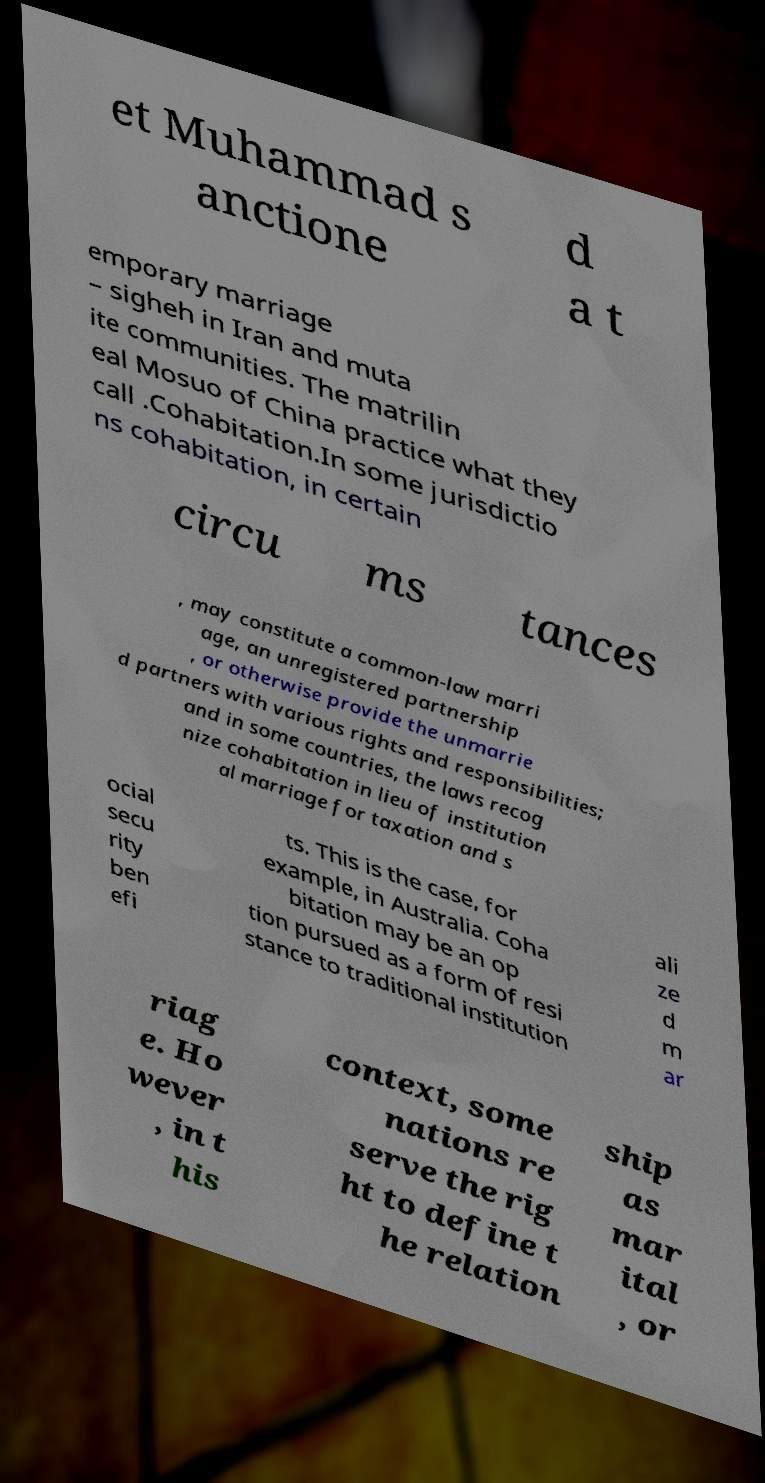What messages or text are displayed in this image? I need them in a readable, typed format. et Muhammad s anctione d a t emporary marriage – sigheh in Iran and muta ite communities. The matrilin eal Mosuo of China practice what they call .Cohabitation.In some jurisdictio ns cohabitation, in certain circu ms tances , may constitute a common-law marri age, an unregistered partnership , or otherwise provide the unmarrie d partners with various rights and responsibilities; and in some countries, the laws recog nize cohabitation in lieu of institution al marriage for taxation and s ocial secu rity ben efi ts. This is the case, for example, in Australia. Coha bitation may be an op tion pursued as a form of resi stance to traditional institution ali ze d m ar riag e. Ho wever , in t his context, some nations re serve the rig ht to define t he relation ship as mar ital , or 